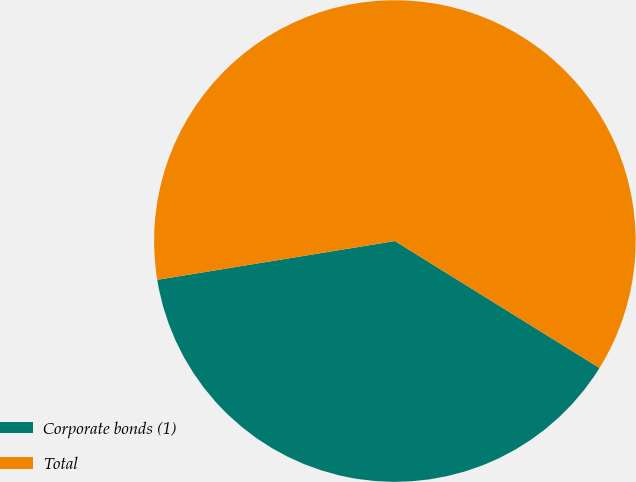Convert chart to OTSL. <chart><loc_0><loc_0><loc_500><loc_500><pie_chart><fcel>Corporate bonds (1)<fcel>Total<nl><fcel>38.59%<fcel>61.41%<nl></chart> 